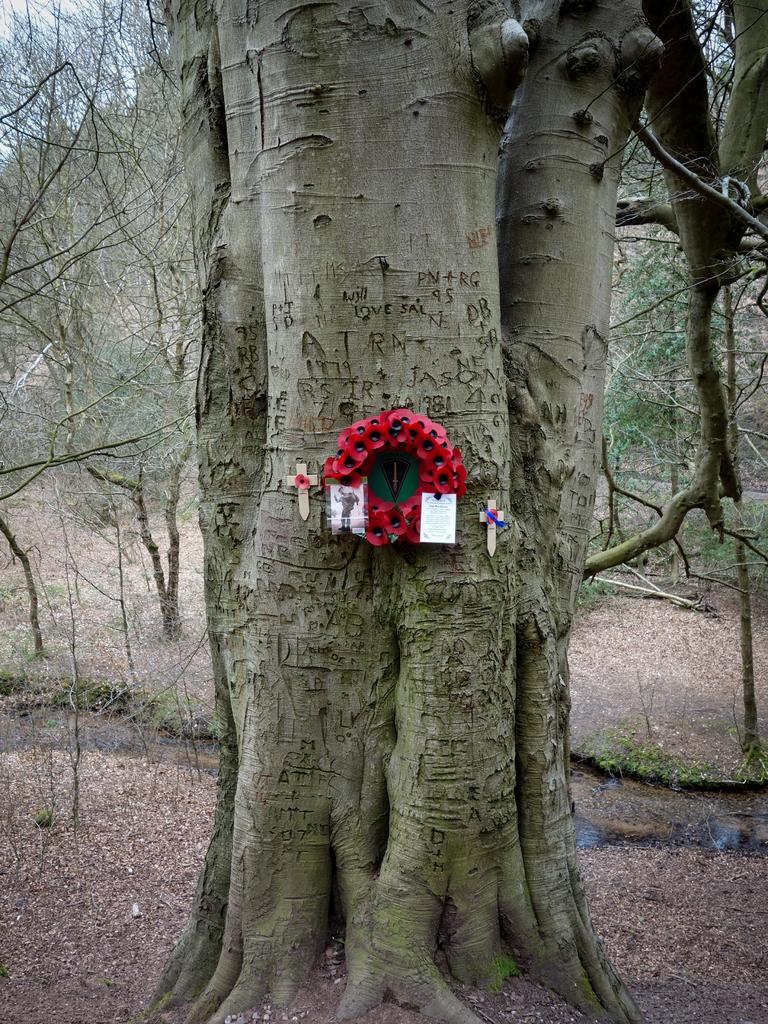Please provide a concise description of this image. In the foreground of the pictures there are dry leaves, trunk of a tree and other objects. In the background there are trees, dry leaves and sky. 